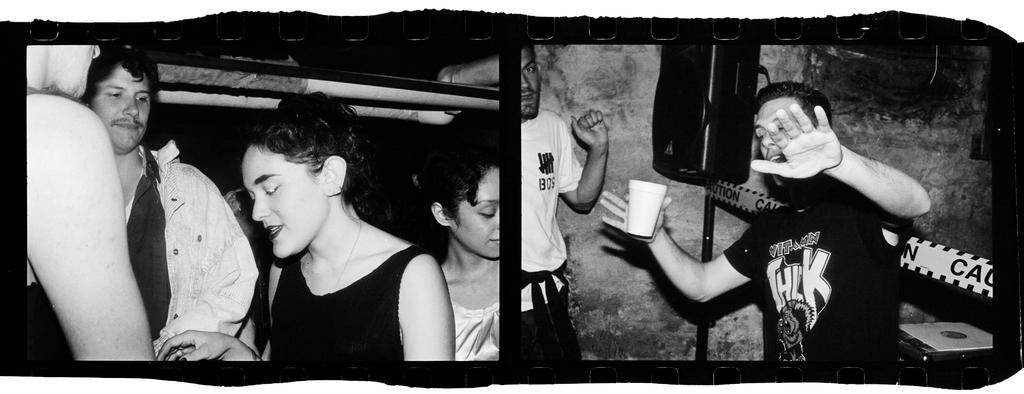How would you summarize this image in a sentence or two? This picture is an black and white image and the image is college. In this image, on the right side, we can see two men and one man is holding a glass in his hand. On the left side, we can see group of people. 